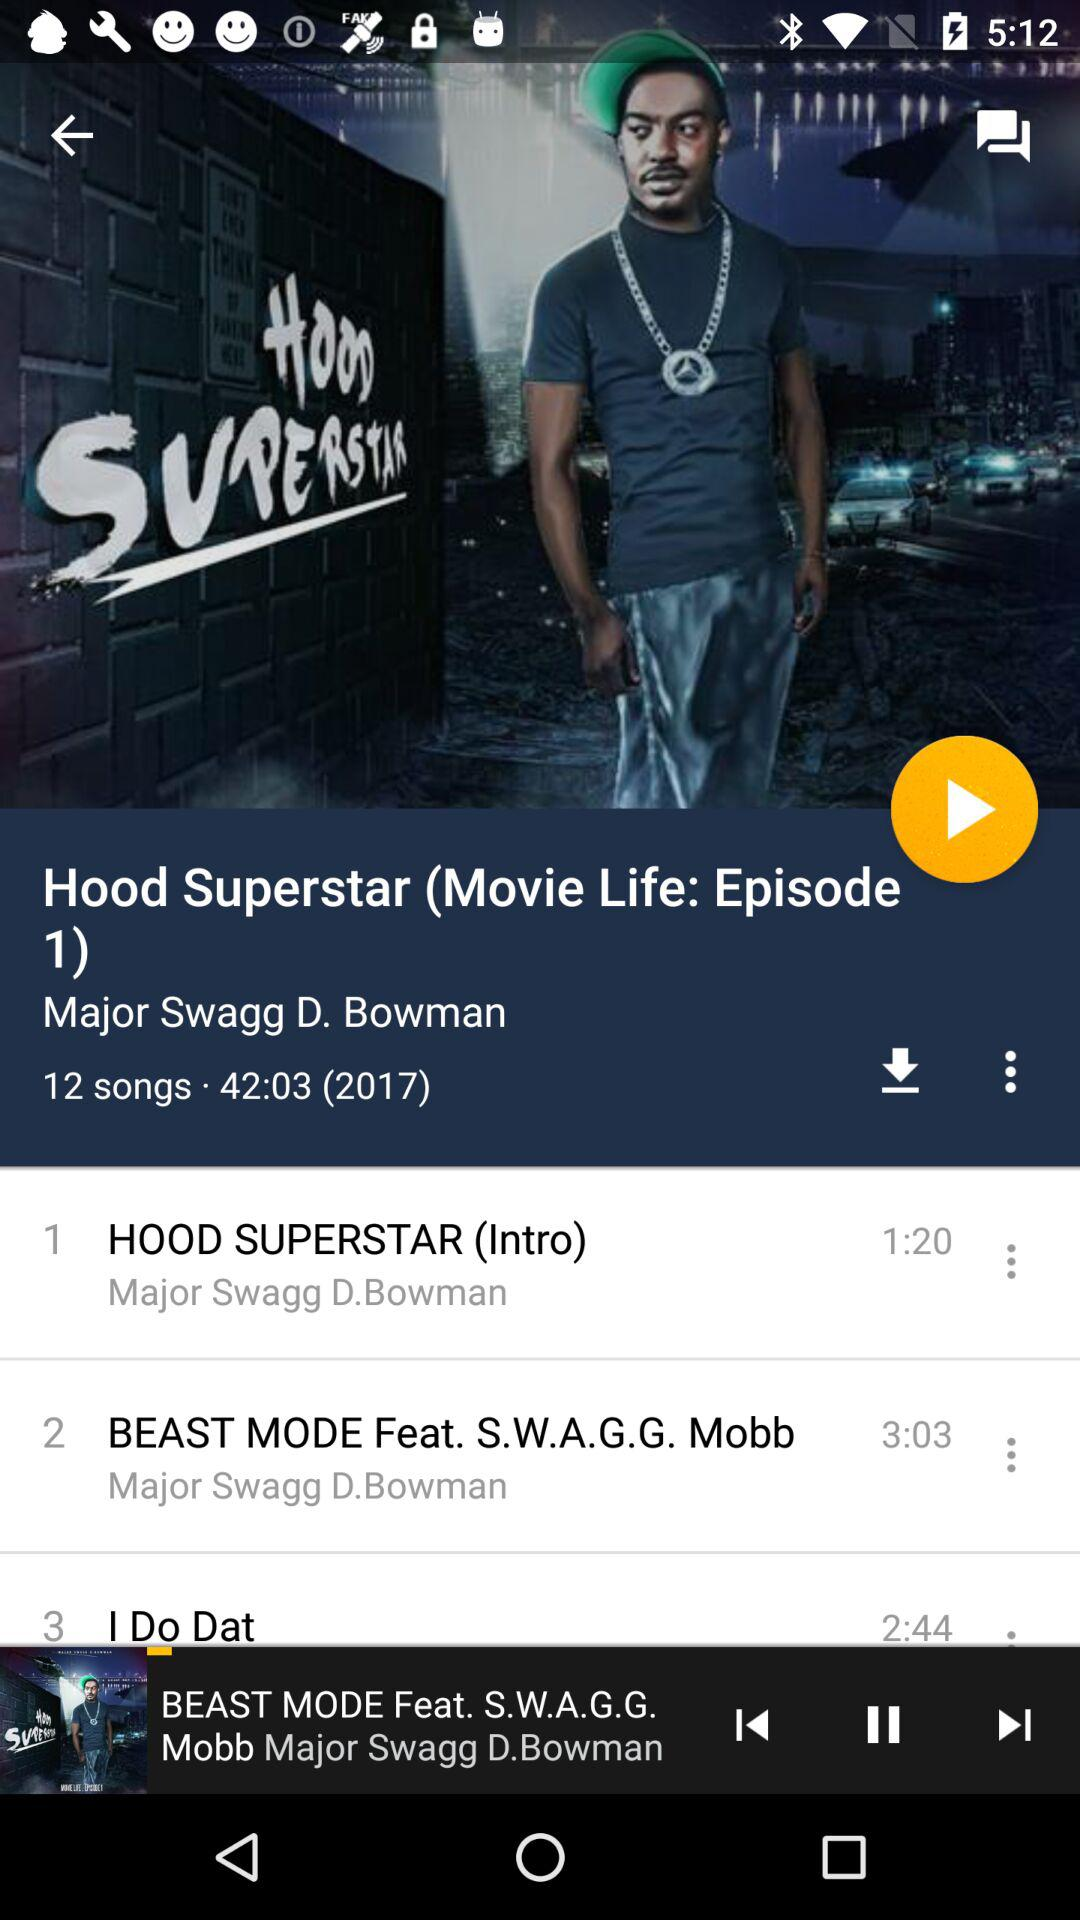Who is the singer of Hood Superstar? The singer is Major Swagg D. Bowman. 